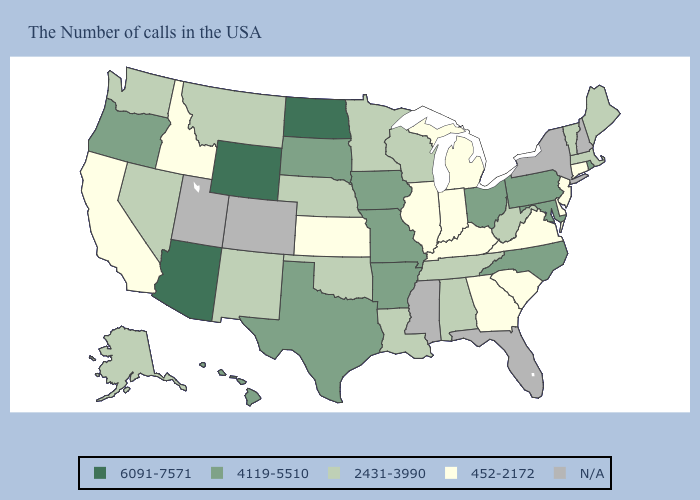What is the value of Hawaii?
Give a very brief answer. 4119-5510. Does Arizona have the highest value in the USA?
Quick response, please. Yes. Which states have the lowest value in the West?
Keep it brief. Idaho, California. Among the states that border Indiana , which have the lowest value?
Be succinct. Michigan, Kentucky, Illinois. Does Kansas have the lowest value in the MidWest?
Answer briefly. Yes. Name the states that have a value in the range 452-2172?
Short answer required. Connecticut, New Jersey, Delaware, Virginia, South Carolina, Georgia, Michigan, Kentucky, Indiana, Illinois, Kansas, Idaho, California. Which states have the highest value in the USA?
Answer briefly. North Dakota, Wyoming, Arizona. Name the states that have a value in the range 6091-7571?
Give a very brief answer. North Dakota, Wyoming, Arizona. What is the lowest value in states that border South Carolina?
Concise answer only. 452-2172. What is the lowest value in the USA?
Give a very brief answer. 452-2172. What is the highest value in states that border Florida?
Be succinct. 2431-3990. Name the states that have a value in the range 4119-5510?
Write a very short answer. Rhode Island, Maryland, Pennsylvania, North Carolina, Ohio, Missouri, Arkansas, Iowa, Texas, South Dakota, Oregon, Hawaii. Name the states that have a value in the range 4119-5510?
Keep it brief. Rhode Island, Maryland, Pennsylvania, North Carolina, Ohio, Missouri, Arkansas, Iowa, Texas, South Dakota, Oregon, Hawaii. What is the lowest value in the USA?
Concise answer only. 452-2172. 